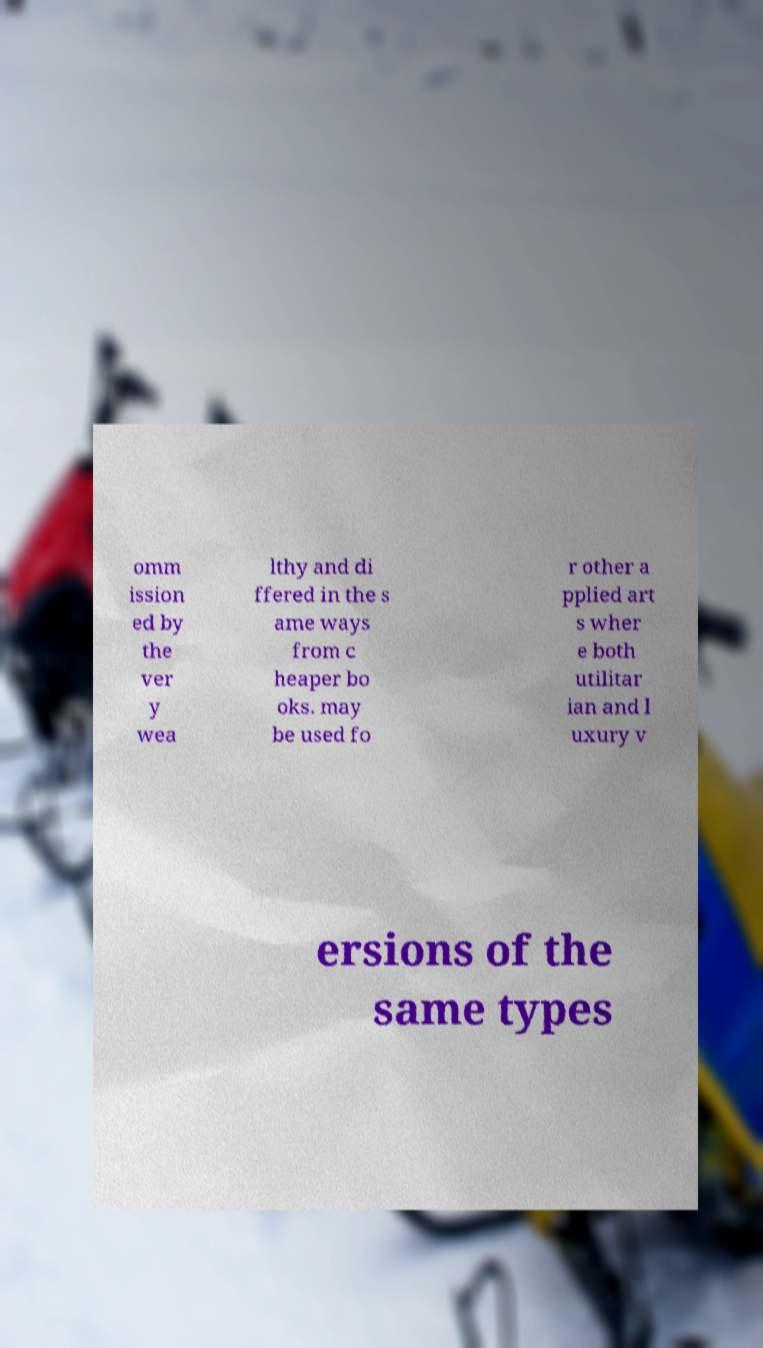For documentation purposes, I need the text within this image transcribed. Could you provide that? omm ission ed by the ver y wea lthy and di ffered in the s ame ways from c heaper bo oks. may be used fo r other a pplied art s wher e both utilitar ian and l uxury v ersions of the same types 